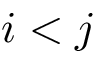<formula> <loc_0><loc_0><loc_500><loc_500>i < j</formula> 